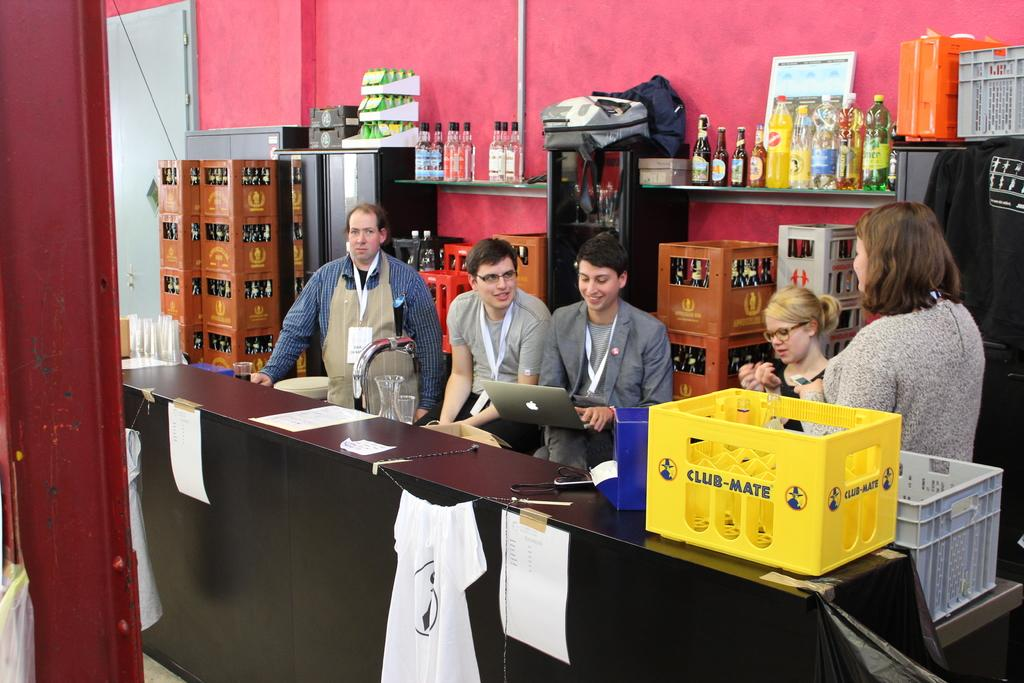<image>
Offer a succinct explanation of the picture presented. Five people sit behind a desk with a yellow container that states CLUB-MATE to the left side of them 